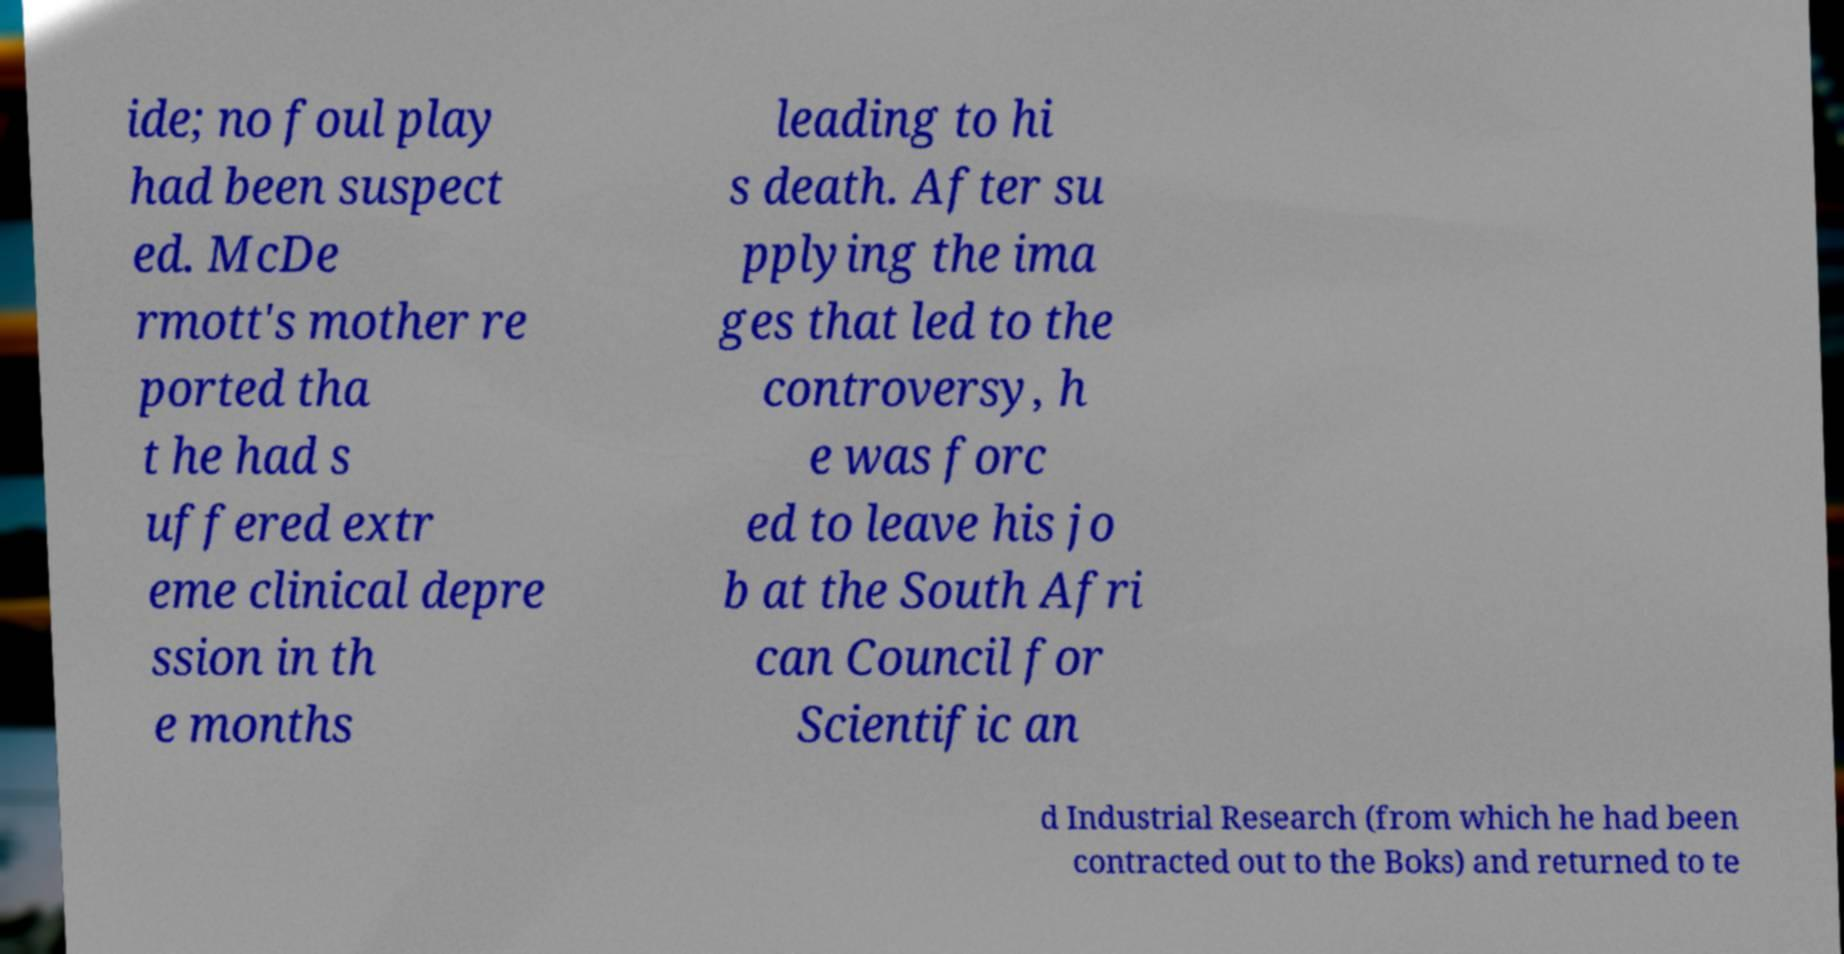There's text embedded in this image that I need extracted. Can you transcribe it verbatim? ide; no foul play had been suspect ed. McDe rmott's mother re ported tha t he had s uffered extr eme clinical depre ssion in th e months leading to hi s death. After su pplying the ima ges that led to the controversy, h e was forc ed to leave his jo b at the South Afri can Council for Scientific an d Industrial Research (from which he had been contracted out to the Boks) and returned to te 